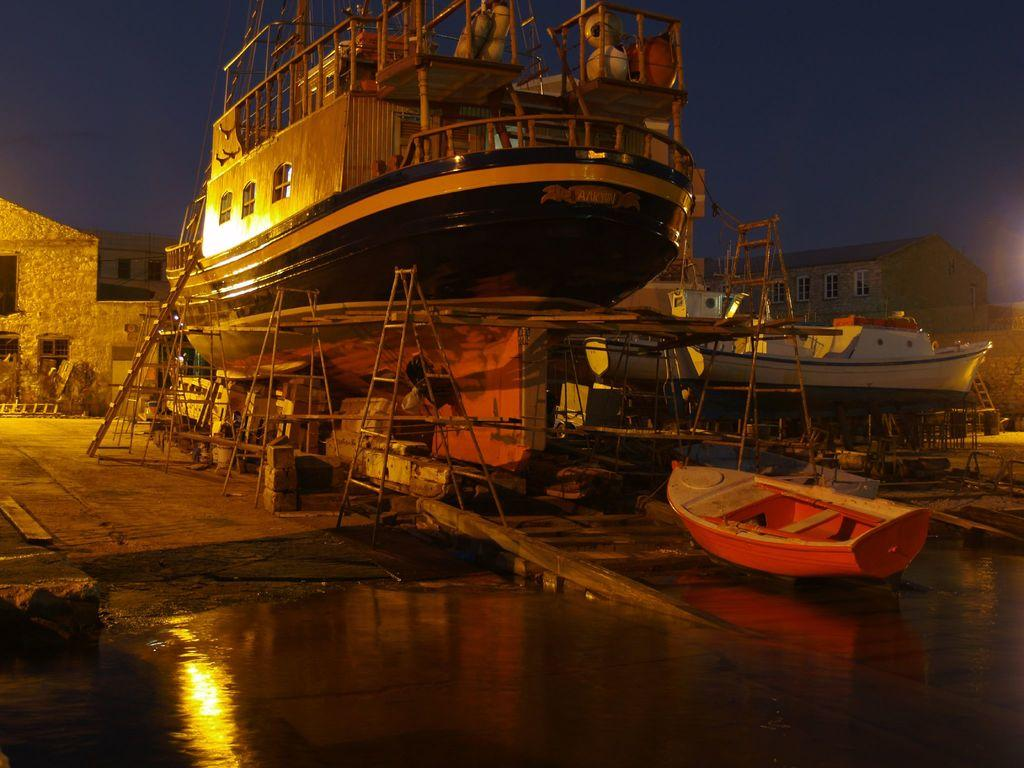What type of watercraft can be seen in the image? There are boats and a ship in the image. What structures are present in the image? There are buildings in the image. What type of equipment is visible in the image? There are ladders in the image. What material is present in the image? There are bricks in the image. What natural element is visible in the image? There is water visible in the image. What is visible in the background of the image? The sky is visible in the background of the image. Can you see the daughter of the ship's captain in the image? There is no person, including the daughter of the ship's captain, visible in the image. Can you see a squirrel climbing one of the ladders in the image? There are no animals, including squirrels, visible in the image. 